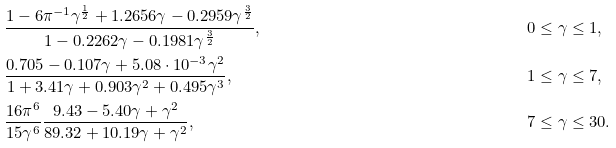Convert formula to latex. <formula><loc_0><loc_0><loc_500><loc_500>& \frac { 1 - 6 \pi ^ { - 1 } \gamma ^ { \frac { 1 } { 2 } } + 1 . 2 6 5 6 \gamma - 0 . 2 9 5 9 \gamma ^ { \frac { 3 } { 2 } } } { 1 - 0 . 2 2 6 2 \gamma - 0 . 1 9 8 1 \gamma ^ { \frac { 3 } { 2 } } } , & & 0 \leq \gamma \leq 1 , \\ & \frac { 0 . 7 0 5 - 0 . 1 0 7 \gamma + 5 . 0 8 \cdot 1 0 ^ { - 3 } \gamma ^ { 2 } } { 1 + 3 . 4 1 \gamma + 0 . 9 0 3 \gamma ^ { 2 } + 0 . 4 9 5 \gamma ^ { 3 } } , & & 1 \leq \gamma \leq 7 , \\ & \frac { 1 6 \pi ^ { 6 } } { 1 5 \gamma ^ { 6 } } \frac { 9 . 4 3 - 5 . 4 0 \gamma + \gamma ^ { 2 } } { 8 9 . 3 2 + 1 0 . 1 9 \gamma + \gamma ^ { 2 } } , & & 7 \leq \gamma \leq 3 0 .</formula> 